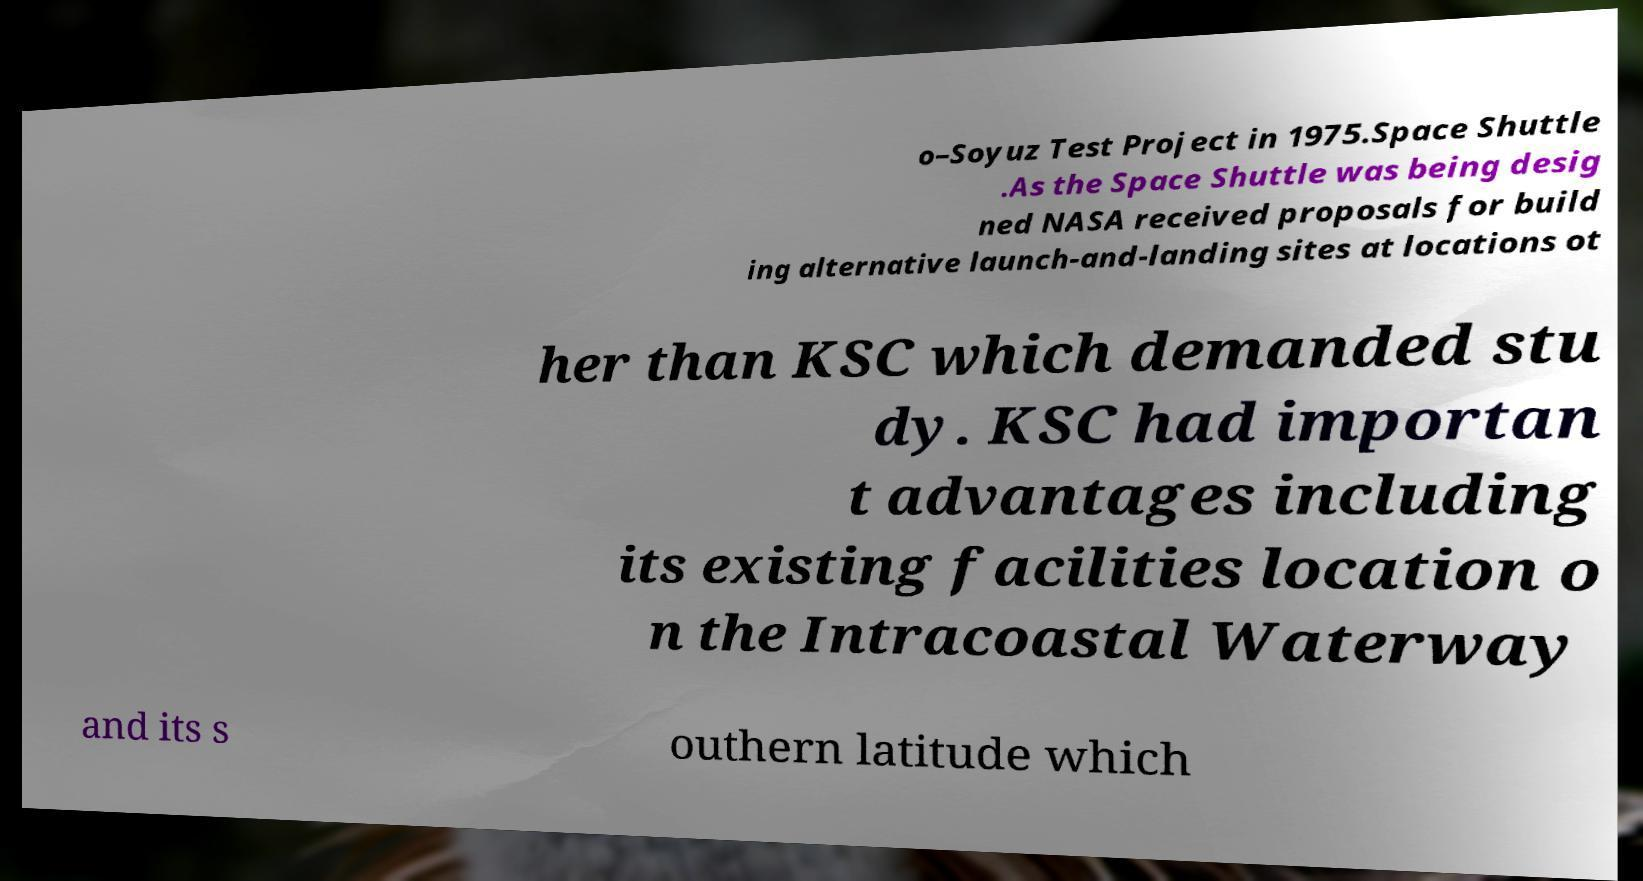Please read and relay the text visible in this image. What does it say? o–Soyuz Test Project in 1975.Space Shuttle .As the Space Shuttle was being desig ned NASA received proposals for build ing alternative launch-and-landing sites at locations ot her than KSC which demanded stu dy. KSC had importan t advantages including its existing facilities location o n the Intracoastal Waterway and its s outhern latitude which 